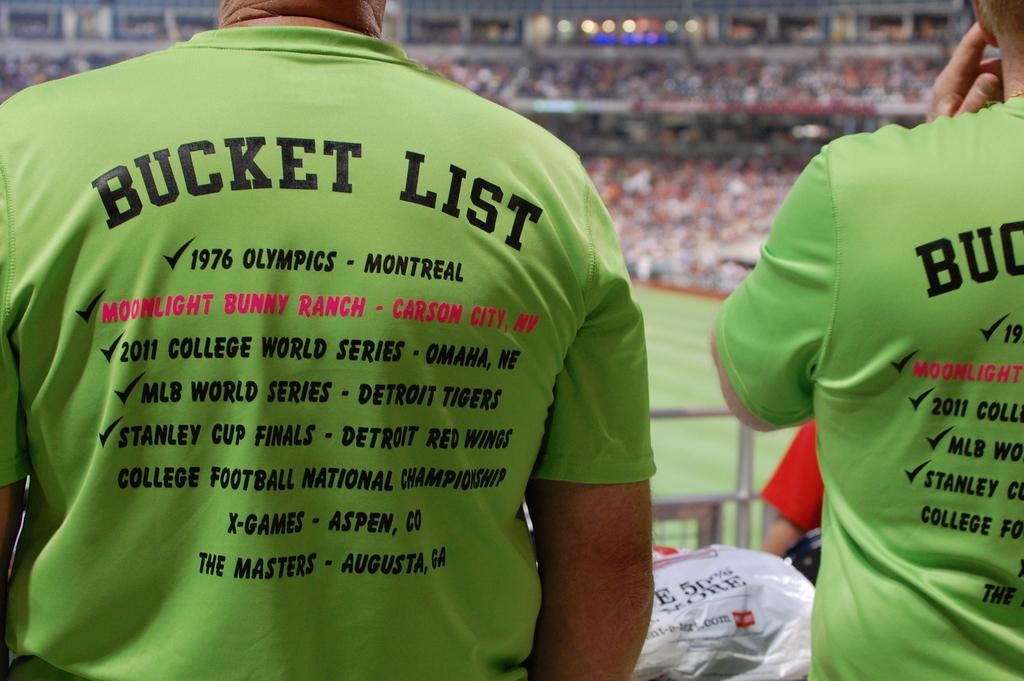<image>
Create a compact narrative representing the image presented. Two people wearing tee shirts with bucket list on the back 